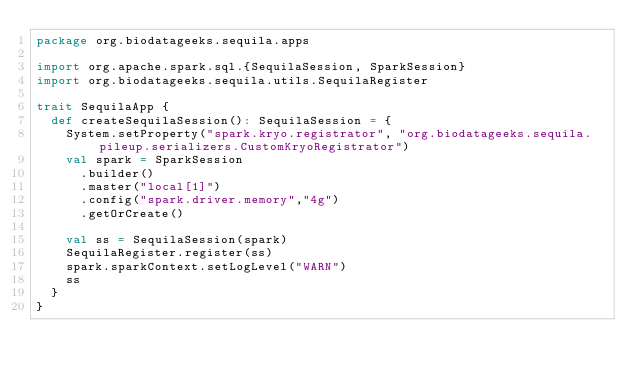<code> <loc_0><loc_0><loc_500><loc_500><_Scala_>package org.biodatageeks.sequila.apps

import org.apache.spark.sql.{SequilaSession, SparkSession}
import org.biodatageeks.sequila.utils.SequilaRegister

trait SequilaApp {
  def createSequilaSession(): SequilaSession = {
    System.setProperty("spark.kryo.registrator", "org.biodatageeks.sequila.pileup.serializers.CustomKryoRegistrator")
    val spark = SparkSession
      .builder()
      .master("local[1]")
      .config("spark.driver.memory","4g")
      .getOrCreate()

    val ss = SequilaSession(spark)
    SequilaRegister.register(ss)
    spark.sparkContext.setLogLevel("WARN")
    ss
  }
}
</code> 